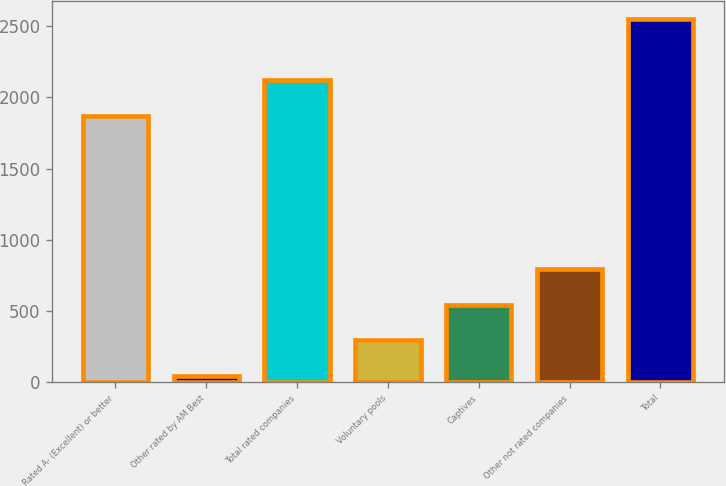Convert chart to OTSL. <chart><loc_0><loc_0><loc_500><loc_500><bar_chart><fcel>Rated A- (Excellent) or better<fcel>Other rated by AM Best<fcel>Total rated companies<fcel>Voluntary pools<fcel>Captives<fcel>Other not rated companies<fcel>Total<nl><fcel>1869<fcel>43<fcel>2119.4<fcel>293.4<fcel>543.8<fcel>794.2<fcel>2547<nl></chart> 